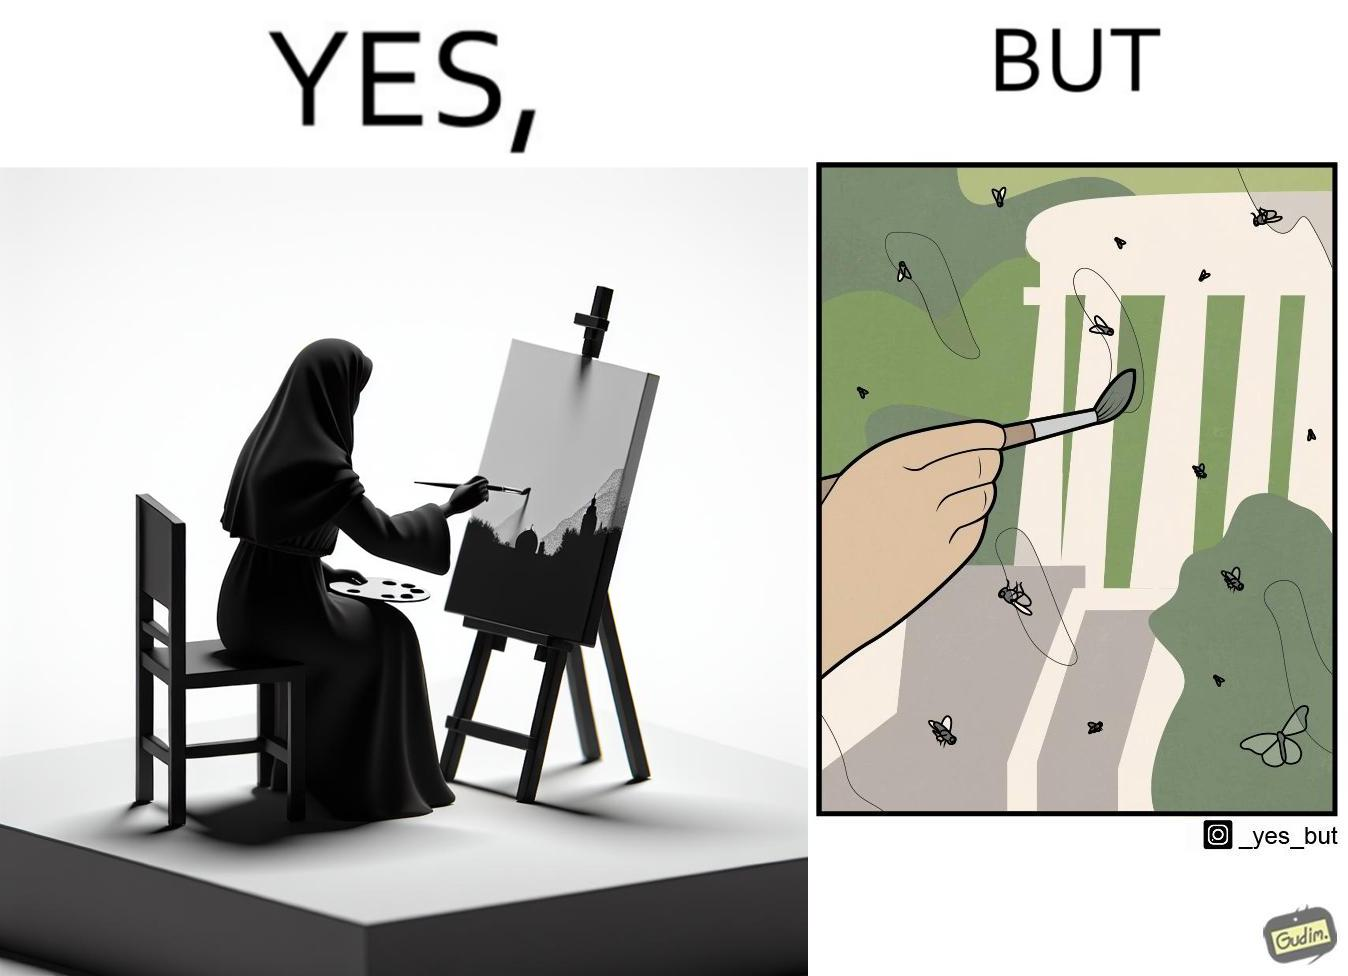Describe the satirical element in this image. The images are funny since they show how a peaceful sight like a woman painting a natural scenery looks good only from afar. When looked closely we can see details like flies on the painting which make us uneasy and the scene is not so good to look at anymore. 